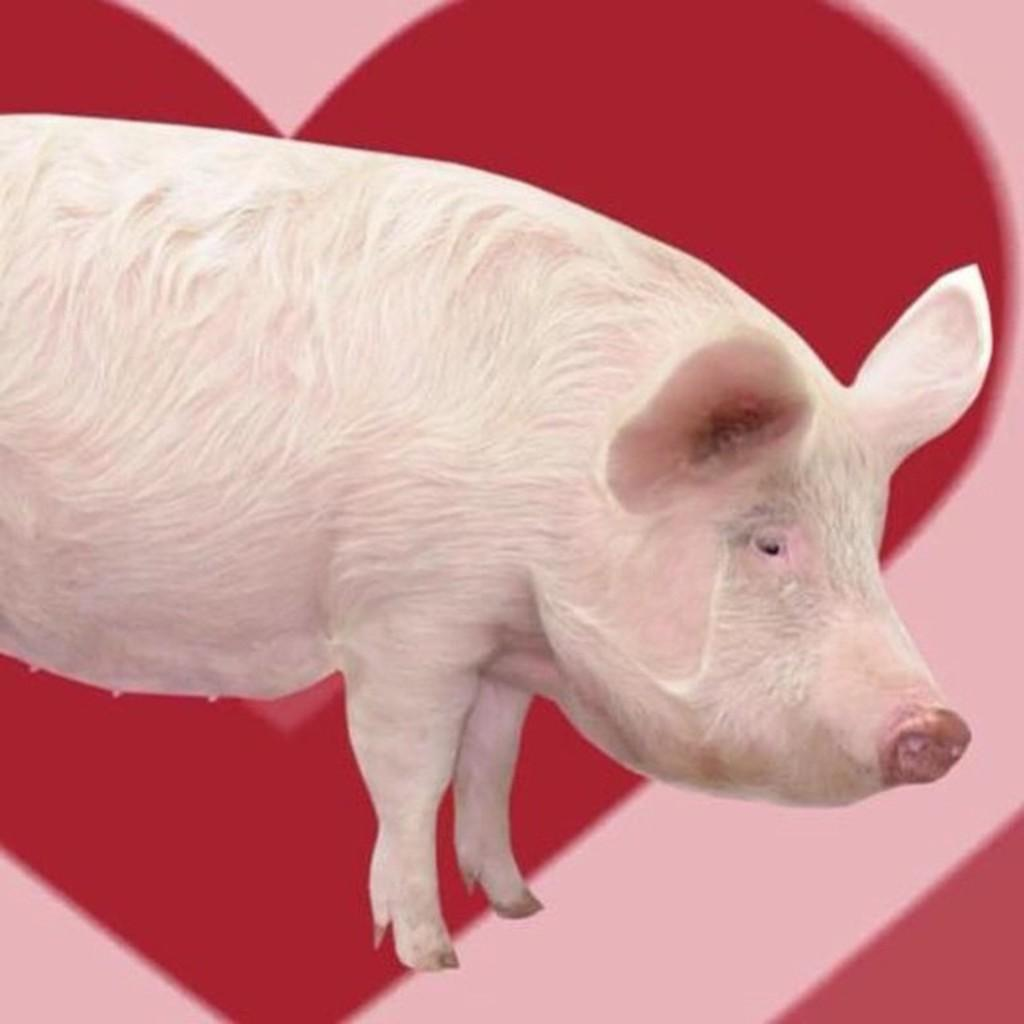What type of animal is in the image? The image contains a white pig. What can be seen in the background of the image? There is a poster in the background of the image. What colors are used on the poster? The poster has red and pink colors. What type of creature is the pig's father in the image? There is no information about the pig's father in the image, and no creature is mentioned. 